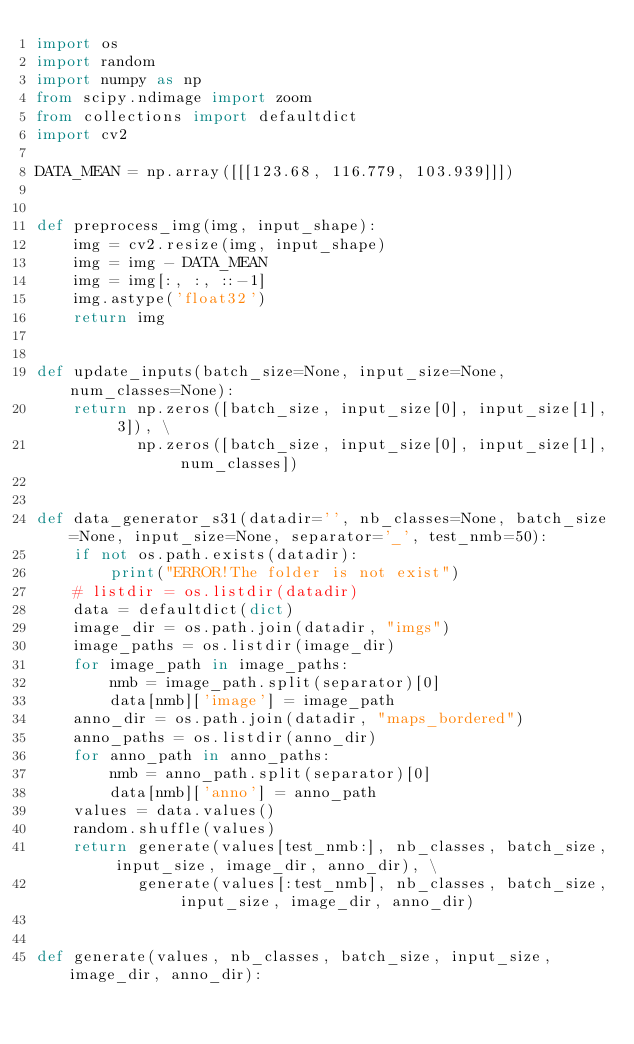<code> <loc_0><loc_0><loc_500><loc_500><_Python_>import os
import random
import numpy as np
from scipy.ndimage import zoom
from collections import defaultdict
import cv2

DATA_MEAN = np.array([[[123.68, 116.779, 103.939]]])


def preprocess_img(img, input_shape):
    img = cv2.resize(img, input_shape)
    img = img - DATA_MEAN
    img = img[:, :, ::-1]
    img.astype('float32')
    return img


def update_inputs(batch_size=None, input_size=None, num_classes=None):
    return np.zeros([batch_size, input_size[0], input_size[1], 3]), \
           np.zeros([batch_size, input_size[0], input_size[1], num_classes])


def data_generator_s31(datadir='', nb_classes=None, batch_size=None, input_size=None, separator='_', test_nmb=50):
    if not os.path.exists(datadir):
        print("ERROR!The folder is not exist")
    # listdir = os.listdir(datadir)
    data = defaultdict(dict)
    image_dir = os.path.join(datadir, "imgs")
    image_paths = os.listdir(image_dir)
    for image_path in image_paths:
        nmb = image_path.split(separator)[0]
        data[nmb]['image'] = image_path
    anno_dir = os.path.join(datadir, "maps_bordered")
    anno_paths = os.listdir(anno_dir)
    for anno_path in anno_paths:
        nmb = anno_path.split(separator)[0]
        data[nmb]['anno'] = anno_path
    values = data.values()
    random.shuffle(values)
    return generate(values[test_nmb:], nb_classes, batch_size, input_size, image_dir, anno_dir), \
           generate(values[:test_nmb], nb_classes, batch_size, input_size, image_dir, anno_dir)


def generate(values, nb_classes, batch_size, input_size, image_dir, anno_dir):</code> 